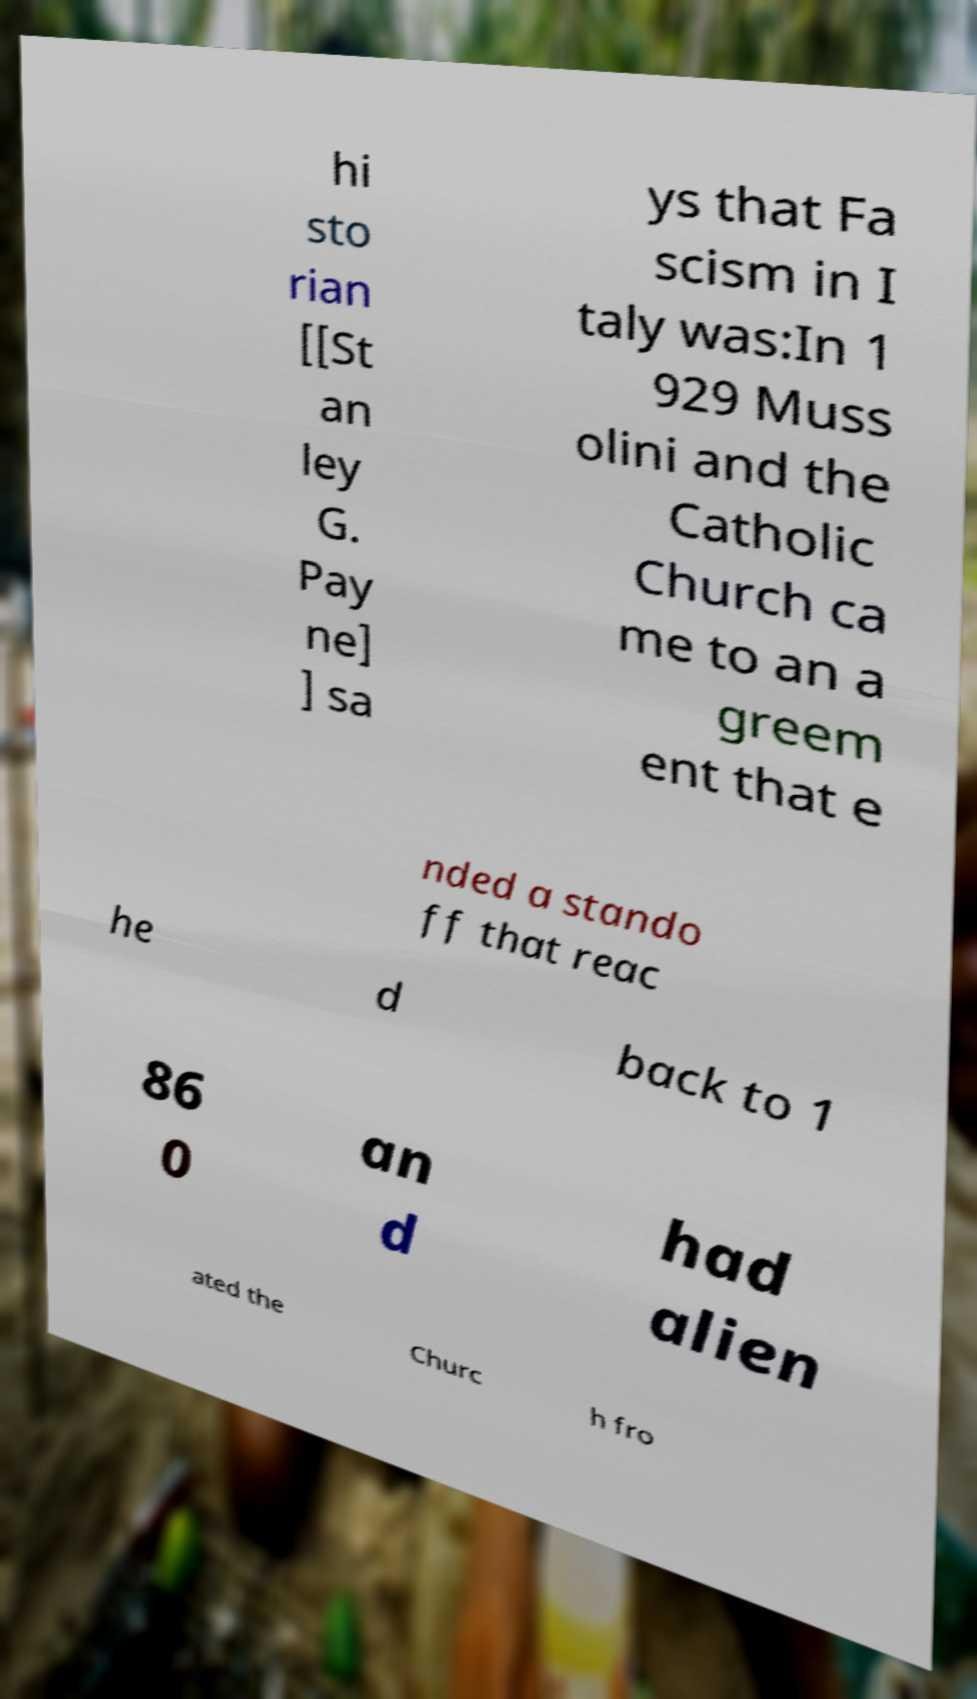Please identify and transcribe the text found in this image. hi sto rian [[St an ley G. Pay ne] ] sa ys that Fa scism in I taly was:In 1 929 Muss olini and the Catholic Church ca me to an a greem ent that e nded a stando ff that reac he d back to 1 86 0 an d had alien ated the Churc h fro 